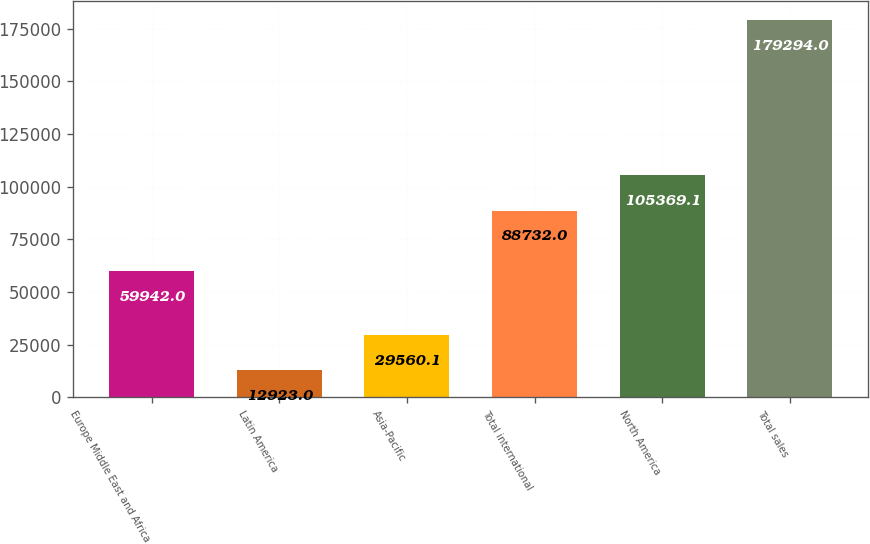Convert chart. <chart><loc_0><loc_0><loc_500><loc_500><bar_chart><fcel>Europe Middle East and Africa<fcel>Latin America<fcel>Asia-Pacific<fcel>Total international<fcel>North America<fcel>Total sales<nl><fcel>59942<fcel>12923<fcel>29560.1<fcel>88732<fcel>105369<fcel>179294<nl></chart> 